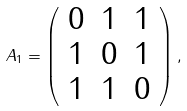Convert formula to latex. <formula><loc_0><loc_0><loc_500><loc_500>A _ { 1 } = \left ( \begin{array} { c c c } 0 & 1 & 1 \\ 1 & 0 & 1 \\ 1 & 1 & 0 \end{array} \right ) ,</formula> 